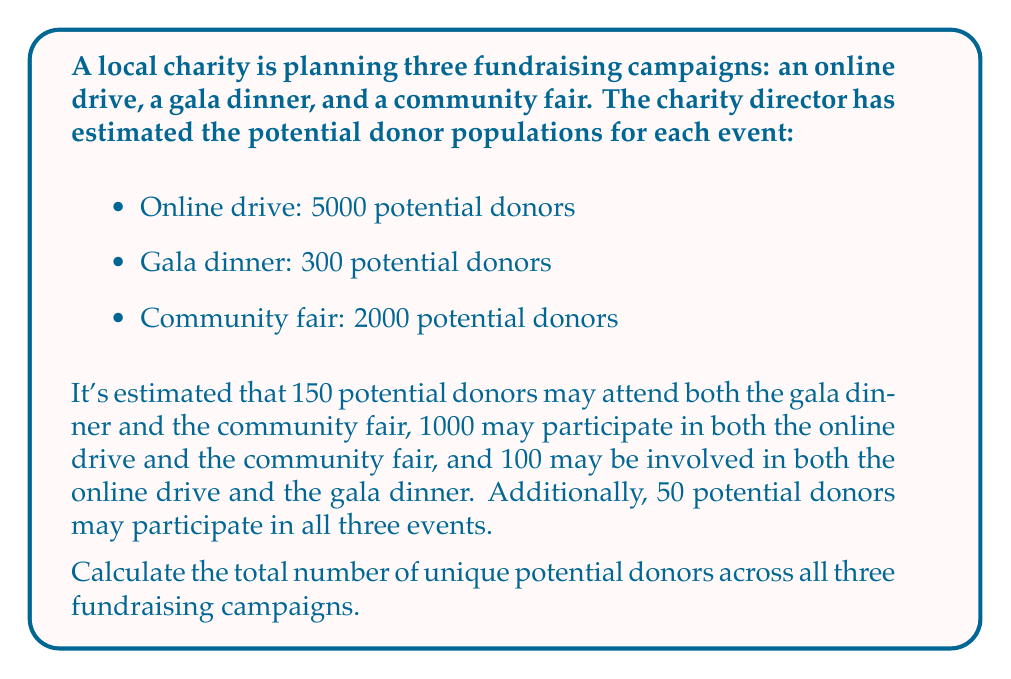Give your solution to this math problem. To solve this problem, we need to use the principle of inclusion-exclusion for three sets. Let's define our sets:

$A$: Online drive donors
$B$: Gala dinner donors
$C$: Community fair donors

We're given:
$|A| = 5000$
$|B| = 300$
$|C| = 2000$
$|A \cap B| = 100$
$|B \cap C| = 150$
$|A \cap C| = 1000$
$|A \cap B \cap C| = 50$

The formula for the union of three sets is:

$$|A \cup B \cup C| = |A| + |B| + |C| - |A \cap B| - |B \cap C| - |A \cap C| + |A \cap B \cap C|$$

Now, let's substitute the values:

$$|A \cup B \cup C| = 5000 + 300 + 2000 - 100 - 150 - 1000 + 50$$

Simplifying:

$$|A \cup B \cup C| = 7300 - 1250 + 50 = 6100$$
Answer: The total number of unique potential donors across all three fundraising campaigns is 6100. 